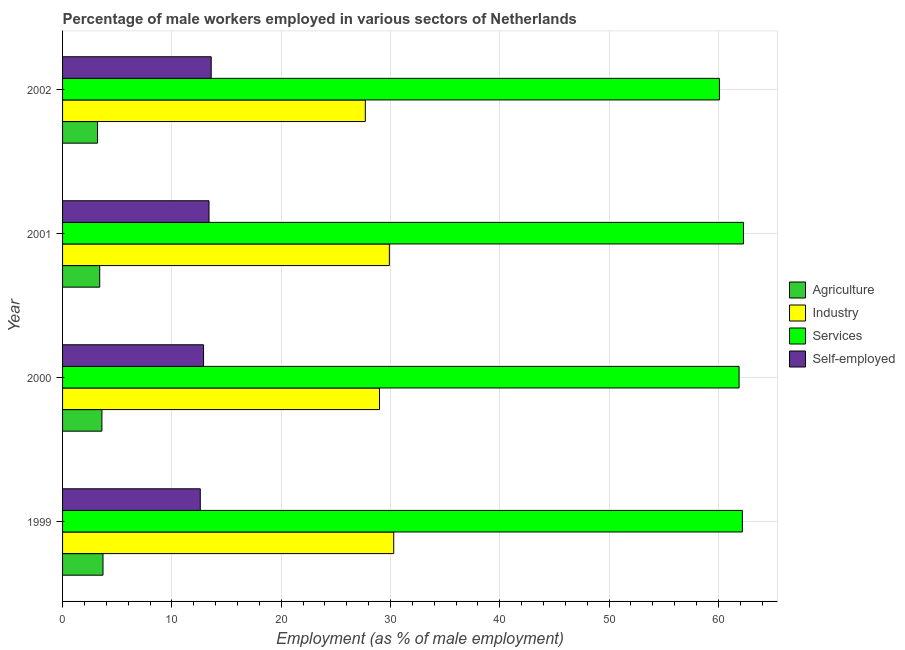How many different coloured bars are there?
Your response must be concise. 4. How many groups of bars are there?
Offer a very short reply. 4. Are the number of bars on each tick of the Y-axis equal?
Your response must be concise. Yes. How many bars are there on the 2nd tick from the top?
Provide a succinct answer. 4. How many bars are there on the 1st tick from the bottom?
Offer a terse response. 4. What is the label of the 4th group of bars from the top?
Offer a very short reply. 1999. What is the percentage of male workers in agriculture in 2000?
Your answer should be very brief. 3.6. Across all years, what is the maximum percentage of male workers in agriculture?
Offer a very short reply. 3.7. Across all years, what is the minimum percentage of self employed male workers?
Keep it short and to the point. 12.6. In which year was the percentage of male workers in agriculture minimum?
Give a very brief answer. 2002. What is the total percentage of self employed male workers in the graph?
Your answer should be very brief. 52.5. What is the difference between the percentage of male workers in services in 2000 and the percentage of male workers in industry in 2002?
Provide a succinct answer. 34.2. What is the average percentage of male workers in services per year?
Your answer should be compact. 61.62. In the year 2000, what is the difference between the percentage of male workers in services and percentage of male workers in agriculture?
Your answer should be compact. 58.3. What is the difference between the highest and the second highest percentage of male workers in agriculture?
Ensure brevity in your answer.  0.1. Is it the case that in every year, the sum of the percentage of male workers in agriculture and percentage of male workers in industry is greater than the sum of percentage of male workers in services and percentage of self employed male workers?
Give a very brief answer. Yes. What does the 4th bar from the top in 2002 represents?
Your response must be concise. Agriculture. What does the 4th bar from the bottom in 1999 represents?
Give a very brief answer. Self-employed. Is it the case that in every year, the sum of the percentage of male workers in agriculture and percentage of male workers in industry is greater than the percentage of male workers in services?
Provide a succinct answer. No. How many bars are there?
Make the answer very short. 16. How many years are there in the graph?
Provide a short and direct response. 4. What is the difference between two consecutive major ticks on the X-axis?
Give a very brief answer. 10. Are the values on the major ticks of X-axis written in scientific E-notation?
Keep it short and to the point. No. Does the graph contain any zero values?
Keep it short and to the point. No. Does the graph contain grids?
Your answer should be very brief. Yes. What is the title of the graph?
Keep it short and to the point. Percentage of male workers employed in various sectors of Netherlands. Does "Self-employed" appear as one of the legend labels in the graph?
Offer a terse response. Yes. What is the label or title of the X-axis?
Make the answer very short. Employment (as % of male employment). What is the Employment (as % of male employment) of Agriculture in 1999?
Provide a succinct answer. 3.7. What is the Employment (as % of male employment) of Industry in 1999?
Offer a terse response. 30.3. What is the Employment (as % of male employment) in Services in 1999?
Your answer should be very brief. 62.2. What is the Employment (as % of male employment) of Self-employed in 1999?
Your answer should be very brief. 12.6. What is the Employment (as % of male employment) of Agriculture in 2000?
Give a very brief answer. 3.6. What is the Employment (as % of male employment) in Services in 2000?
Offer a terse response. 61.9. What is the Employment (as % of male employment) of Self-employed in 2000?
Your response must be concise. 12.9. What is the Employment (as % of male employment) in Agriculture in 2001?
Your response must be concise. 3.4. What is the Employment (as % of male employment) of Industry in 2001?
Provide a short and direct response. 29.9. What is the Employment (as % of male employment) in Services in 2001?
Ensure brevity in your answer.  62.3. What is the Employment (as % of male employment) of Self-employed in 2001?
Provide a short and direct response. 13.4. What is the Employment (as % of male employment) of Agriculture in 2002?
Offer a terse response. 3.2. What is the Employment (as % of male employment) in Industry in 2002?
Give a very brief answer. 27.7. What is the Employment (as % of male employment) in Services in 2002?
Make the answer very short. 60.1. What is the Employment (as % of male employment) in Self-employed in 2002?
Provide a short and direct response. 13.6. Across all years, what is the maximum Employment (as % of male employment) in Agriculture?
Make the answer very short. 3.7. Across all years, what is the maximum Employment (as % of male employment) of Industry?
Offer a terse response. 30.3. Across all years, what is the maximum Employment (as % of male employment) of Services?
Offer a very short reply. 62.3. Across all years, what is the maximum Employment (as % of male employment) of Self-employed?
Offer a terse response. 13.6. Across all years, what is the minimum Employment (as % of male employment) in Agriculture?
Your answer should be compact. 3.2. Across all years, what is the minimum Employment (as % of male employment) of Industry?
Provide a succinct answer. 27.7. Across all years, what is the minimum Employment (as % of male employment) in Services?
Make the answer very short. 60.1. Across all years, what is the minimum Employment (as % of male employment) in Self-employed?
Keep it short and to the point. 12.6. What is the total Employment (as % of male employment) in Agriculture in the graph?
Make the answer very short. 13.9. What is the total Employment (as % of male employment) of Industry in the graph?
Provide a short and direct response. 116.9. What is the total Employment (as % of male employment) in Services in the graph?
Offer a terse response. 246.5. What is the total Employment (as % of male employment) in Self-employed in the graph?
Offer a very short reply. 52.5. What is the difference between the Employment (as % of male employment) of Services in 1999 and that in 2000?
Your answer should be very brief. 0.3. What is the difference between the Employment (as % of male employment) in Self-employed in 1999 and that in 2000?
Your response must be concise. -0.3. What is the difference between the Employment (as % of male employment) of Agriculture in 1999 and that in 2002?
Your answer should be compact. 0.5. What is the difference between the Employment (as % of male employment) in Services in 1999 and that in 2002?
Your answer should be very brief. 2.1. What is the difference between the Employment (as % of male employment) of Agriculture in 2000 and that in 2001?
Provide a short and direct response. 0.2. What is the difference between the Employment (as % of male employment) in Self-employed in 2000 and that in 2001?
Your answer should be very brief. -0.5. What is the difference between the Employment (as % of male employment) in Agriculture in 2000 and that in 2002?
Offer a terse response. 0.4. What is the difference between the Employment (as % of male employment) of Industry in 2000 and that in 2002?
Keep it short and to the point. 1.3. What is the difference between the Employment (as % of male employment) of Services in 2000 and that in 2002?
Provide a succinct answer. 1.8. What is the difference between the Employment (as % of male employment) of Self-employed in 2000 and that in 2002?
Your response must be concise. -0.7. What is the difference between the Employment (as % of male employment) in Services in 2001 and that in 2002?
Offer a very short reply. 2.2. What is the difference between the Employment (as % of male employment) of Self-employed in 2001 and that in 2002?
Give a very brief answer. -0.2. What is the difference between the Employment (as % of male employment) in Agriculture in 1999 and the Employment (as % of male employment) in Industry in 2000?
Provide a short and direct response. -25.3. What is the difference between the Employment (as % of male employment) of Agriculture in 1999 and the Employment (as % of male employment) of Services in 2000?
Provide a short and direct response. -58.2. What is the difference between the Employment (as % of male employment) of Agriculture in 1999 and the Employment (as % of male employment) of Self-employed in 2000?
Your answer should be very brief. -9.2. What is the difference between the Employment (as % of male employment) of Industry in 1999 and the Employment (as % of male employment) of Services in 2000?
Give a very brief answer. -31.6. What is the difference between the Employment (as % of male employment) of Services in 1999 and the Employment (as % of male employment) of Self-employed in 2000?
Give a very brief answer. 49.3. What is the difference between the Employment (as % of male employment) of Agriculture in 1999 and the Employment (as % of male employment) of Industry in 2001?
Offer a very short reply. -26.2. What is the difference between the Employment (as % of male employment) in Agriculture in 1999 and the Employment (as % of male employment) in Services in 2001?
Provide a short and direct response. -58.6. What is the difference between the Employment (as % of male employment) in Industry in 1999 and the Employment (as % of male employment) in Services in 2001?
Give a very brief answer. -32. What is the difference between the Employment (as % of male employment) in Industry in 1999 and the Employment (as % of male employment) in Self-employed in 2001?
Your answer should be very brief. 16.9. What is the difference between the Employment (as % of male employment) in Services in 1999 and the Employment (as % of male employment) in Self-employed in 2001?
Your answer should be compact. 48.8. What is the difference between the Employment (as % of male employment) of Agriculture in 1999 and the Employment (as % of male employment) of Industry in 2002?
Provide a short and direct response. -24. What is the difference between the Employment (as % of male employment) in Agriculture in 1999 and the Employment (as % of male employment) in Services in 2002?
Provide a succinct answer. -56.4. What is the difference between the Employment (as % of male employment) of Industry in 1999 and the Employment (as % of male employment) of Services in 2002?
Your answer should be very brief. -29.8. What is the difference between the Employment (as % of male employment) in Industry in 1999 and the Employment (as % of male employment) in Self-employed in 2002?
Offer a terse response. 16.7. What is the difference between the Employment (as % of male employment) of Services in 1999 and the Employment (as % of male employment) of Self-employed in 2002?
Offer a very short reply. 48.6. What is the difference between the Employment (as % of male employment) of Agriculture in 2000 and the Employment (as % of male employment) of Industry in 2001?
Keep it short and to the point. -26.3. What is the difference between the Employment (as % of male employment) in Agriculture in 2000 and the Employment (as % of male employment) in Services in 2001?
Provide a short and direct response. -58.7. What is the difference between the Employment (as % of male employment) in Agriculture in 2000 and the Employment (as % of male employment) in Self-employed in 2001?
Offer a terse response. -9.8. What is the difference between the Employment (as % of male employment) in Industry in 2000 and the Employment (as % of male employment) in Services in 2001?
Give a very brief answer. -33.3. What is the difference between the Employment (as % of male employment) in Services in 2000 and the Employment (as % of male employment) in Self-employed in 2001?
Your answer should be very brief. 48.5. What is the difference between the Employment (as % of male employment) of Agriculture in 2000 and the Employment (as % of male employment) of Industry in 2002?
Offer a very short reply. -24.1. What is the difference between the Employment (as % of male employment) in Agriculture in 2000 and the Employment (as % of male employment) in Services in 2002?
Offer a very short reply. -56.5. What is the difference between the Employment (as % of male employment) of Industry in 2000 and the Employment (as % of male employment) of Services in 2002?
Provide a succinct answer. -31.1. What is the difference between the Employment (as % of male employment) of Services in 2000 and the Employment (as % of male employment) of Self-employed in 2002?
Your answer should be compact. 48.3. What is the difference between the Employment (as % of male employment) in Agriculture in 2001 and the Employment (as % of male employment) in Industry in 2002?
Your response must be concise. -24.3. What is the difference between the Employment (as % of male employment) in Agriculture in 2001 and the Employment (as % of male employment) in Services in 2002?
Provide a succinct answer. -56.7. What is the difference between the Employment (as % of male employment) of Agriculture in 2001 and the Employment (as % of male employment) of Self-employed in 2002?
Make the answer very short. -10.2. What is the difference between the Employment (as % of male employment) in Industry in 2001 and the Employment (as % of male employment) in Services in 2002?
Ensure brevity in your answer.  -30.2. What is the difference between the Employment (as % of male employment) in Industry in 2001 and the Employment (as % of male employment) in Self-employed in 2002?
Provide a succinct answer. 16.3. What is the difference between the Employment (as % of male employment) of Services in 2001 and the Employment (as % of male employment) of Self-employed in 2002?
Keep it short and to the point. 48.7. What is the average Employment (as % of male employment) in Agriculture per year?
Provide a succinct answer. 3.48. What is the average Employment (as % of male employment) of Industry per year?
Keep it short and to the point. 29.23. What is the average Employment (as % of male employment) in Services per year?
Offer a very short reply. 61.62. What is the average Employment (as % of male employment) in Self-employed per year?
Offer a terse response. 13.12. In the year 1999, what is the difference between the Employment (as % of male employment) of Agriculture and Employment (as % of male employment) of Industry?
Your answer should be very brief. -26.6. In the year 1999, what is the difference between the Employment (as % of male employment) in Agriculture and Employment (as % of male employment) in Services?
Offer a terse response. -58.5. In the year 1999, what is the difference between the Employment (as % of male employment) of Agriculture and Employment (as % of male employment) of Self-employed?
Your answer should be very brief. -8.9. In the year 1999, what is the difference between the Employment (as % of male employment) of Industry and Employment (as % of male employment) of Services?
Offer a very short reply. -31.9. In the year 1999, what is the difference between the Employment (as % of male employment) in Industry and Employment (as % of male employment) in Self-employed?
Your response must be concise. 17.7. In the year 1999, what is the difference between the Employment (as % of male employment) in Services and Employment (as % of male employment) in Self-employed?
Your response must be concise. 49.6. In the year 2000, what is the difference between the Employment (as % of male employment) in Agriculture and Employment (as % of male employment) in Industry?
Offer a very short reply. -25.4. In the year 2000, what is the difference between the Employment (as % of male employment) of Agriculture and Employment (as % of male employment) of Services?
Offer a terse response. -58.3. In the year 2000, what is the difference between the Employment (as % of male employment) in Agriculture and Employment (as % of male employment) in Self-employed?
Make the answer very short. -9.3. In the year 2000, what is the difference between the Employment (as % of male employment) in Industry and Employment (as % of male employment) in Services?
Provide a short and direct response. -32.9. In the year 2000, what is the difference between the Employment (as % of male employment) of Industry and Employment (as % of male employment) of Self-employed?
Provide a succinct answer. 16.1. In the year 2000, what is the difference between the Employment (as % of male employment) in Services and Employment (as % of male employment) in Self-employed?
Make the answer very short. 49. In the year 2001, what is the difference between the Employment (as % of male employment) of Agriculture and Employment (as % of male employment) of Industry?
Offer a very short reply. -26.5. In the year 2001, what is the difference between the Employment (as % of male employment) in Agriculture and Employment (as % of male employment) in Services?
Provide a short and direct response. -58.9. In the year 2001, what is the difference between the Employment (as % of male employment) of Industry and Employment (as % of male employment) of Services?
Your answer should be compact. -32.4. In the year 2001, what is the difference between the Employment (as % of male employment) of Industry and Employment (as % of male employment) of Self-employed?
Offer a terse response. 16.5. In the year 2001, what is the difference between the Employment (as % of male employment) of Services and Employment (as % of male employment) of Self-employed?
Offer a very short reply. 48.9. In the year 2002, what is the difference between the Employment (as % of male employment) in Agriculture and Employment (as % of male employment) in Industry?
Offer a very short reply. -24.5. In the year 2002, what is the difference between the Employment (as % of male employment) in Agriculture and Employment (as % of male employment) in Services?
Ensure brevity in your answer.  -56.9. In the year 2002, what is the difference between the Employment (as % of male employment) in Agriculture and Employment (as % of male employment) in Self-employed?
Offer a terse response. -10.4. In the year 2002, what is the difference between the Employment (as % of male employment) in Industry and Employment (as % of male employment) in Services?
Keep it short and to the point. -32.4. In the year 2002, what is the difference between the Employment (as % of male employment) in Industry and Employment (as % of male employment) in Self-employed?
Your answer should be compact. 14.1. In the year 2002, what is the difference between the Employment (as % of male employment) of Services and Employment (as % of male employment) of Self-employed?
Provide a succinct answer. 46.5. What is the ratio of the Employment (as % of male employment) of Agriculture in 1999 to that in 2000?
Provide a short and direct response. 1.03. What is the ratio of the Employment (as % of male employment) of Industry in 1999 to that in 2000?
Your response must be concise. 1.04. What is the ratio of the Employment (as % of male employment) of Self-employed in 1999 to that in 2000?
Ensure brevity in your answer.  0.98. What is the ratio of the Employment (as % of male employment) of Agriculture in 1999 to that in 2001?
Your answer should be compact. 1.09. What is the ratio of the Employment (as % of male employment) of Industry in 1999 to that in 2001?
Ensure brevity in your answer.  1.01. What is the ratio of the Employment (as % of male employment) in Services in 1999 to that in 2001?
Your response must be concise. 1. What is the ratio of the Employment (as % of male employment) of Self-employed in 1999 to that in 2001?
Provide a succinct answer. 0.94. What is the ratio of the Employment (as % of male employment) of Agriculture in 1999 to that in 2002?
Give a very brief answer. 1.16. What is the ratio of the Employment (as % of male employment) of Industry in 1999 to that in 2002?
Provide a succinct answer. 1.09. What is the ratio of the Employment (as % of male employment) of Services in 1999 to that in 2002?
Provide a short and direct response. 1.03. What is the ratio of the Employment (as % of male employment) of Self-employed in 1999 to that in 2002?
Provide a succinct answer. 0.93. What is the ratio of the Employment (as % of male employment) of Agriculture in 2000 to that in 2001?
Your answer should be compact. 1.06. What is the ratio of the Employment (as % of male employment) in Industry in 2000 to that in 2001?
Keep it short and to the point. 0.97. What is the ratio of the Employment (as % of male employment) in Self-employed in 2000 to that in 2001?
Your answer should be very brief. 0.96. What is the ratio of the Employment (as % of male employment) in Industry in 2000 to that in 2002?
Your answer should be very brief. 1.05. What is the ratio of the Employment (as % of male employment) of Self-employed in 2000 to that in 2002?
Your answer should be very brief. 0.95. What is the ratio of the Employment (as % of male employment) of Industry in 2001 to that in 2002?
Provide a short and direct response. 1.08. What is the ratio of the Employment (as % of male employment) of Services in 2001 to that in 2002?
Offer a terse response. 1.04. What is the difference between the highest and the second highest Employment (as % of male employment) in Agriculture?
Your response must be concise. 0.1. What is the difference between the highest and the lowest Employment (as % of male employment) of Industry?
Provide a short and direct response. 2.6. What is the difference between the highest and the lowest Employment (as % of male employment) in Services?
Make the answer very short. 2.2. 